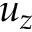Convert formula to latex. <formula><loc_0><loc_0><loc_500><loc_500>u _ { z }</formula> 